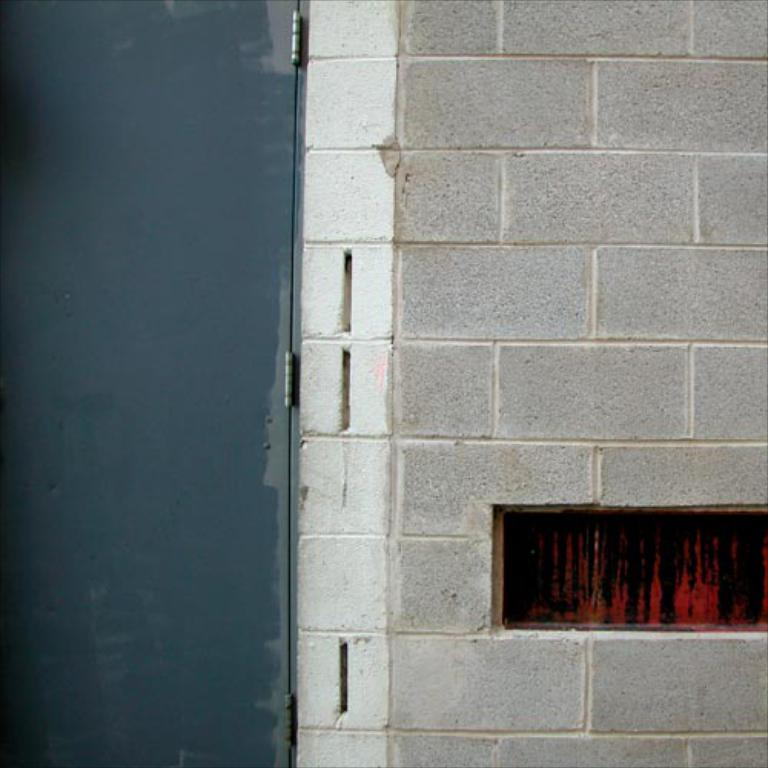What type of wall is visible in the image? There is a brick wall in the image. What is the door made of in the image? There is an iron door in the image. What did the mother pack for lunch in the image? There is no mention of a mother or lunch in the image; it only features a brick wall and an iron door. 